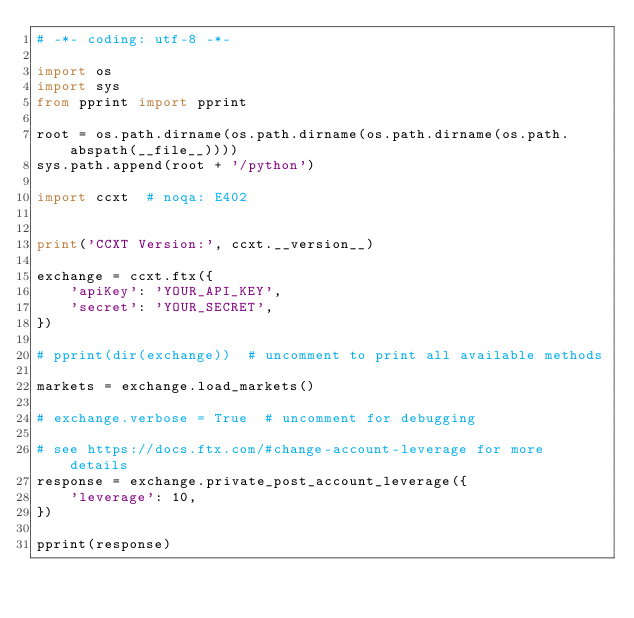Convert code to text. <code><loc_0><loc_0><loc_500><loc_500><_Python_># -*- coding: utf-8 -*-

import os
import sys
from pprint import pprint

root = os.path.dirname(os.path.dirname(os.path.dirname(os.path.abspath(__file__))))
sys.path.append(root + '/python')

import ccxt  # noqa: E402


print('CCXT Version:', ccxt.__version__)

exchange = ccxt.ftx({
    'apiKey': 'YOUR_API_KEY',
    'secret': 'YOUR_SECRET',
})

# pprint(dir(exchange))  # uncomment to print all available methods

markets = exchange.load_markets()

# exchange.verbose = True  # uncomment for debugging

# see https://docs.ftx.com/#change-account-leverage for more details
response = exchange.private_post_account_leverage({
    'leverage': 10,
})

pprint(response)
</code> 